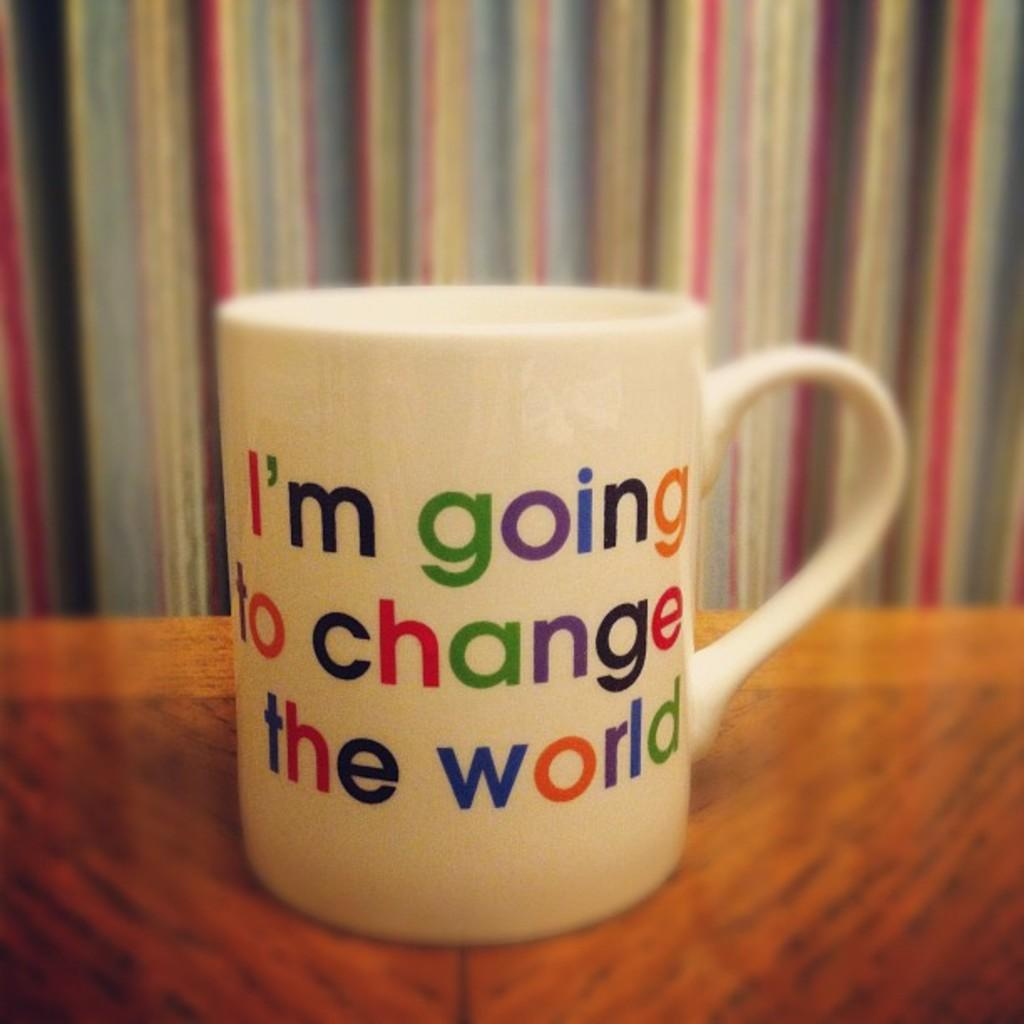<image>
Present a compact description of the photo's key features. The white mug features rainbow colored lettering stating "I'm going to change the world". 